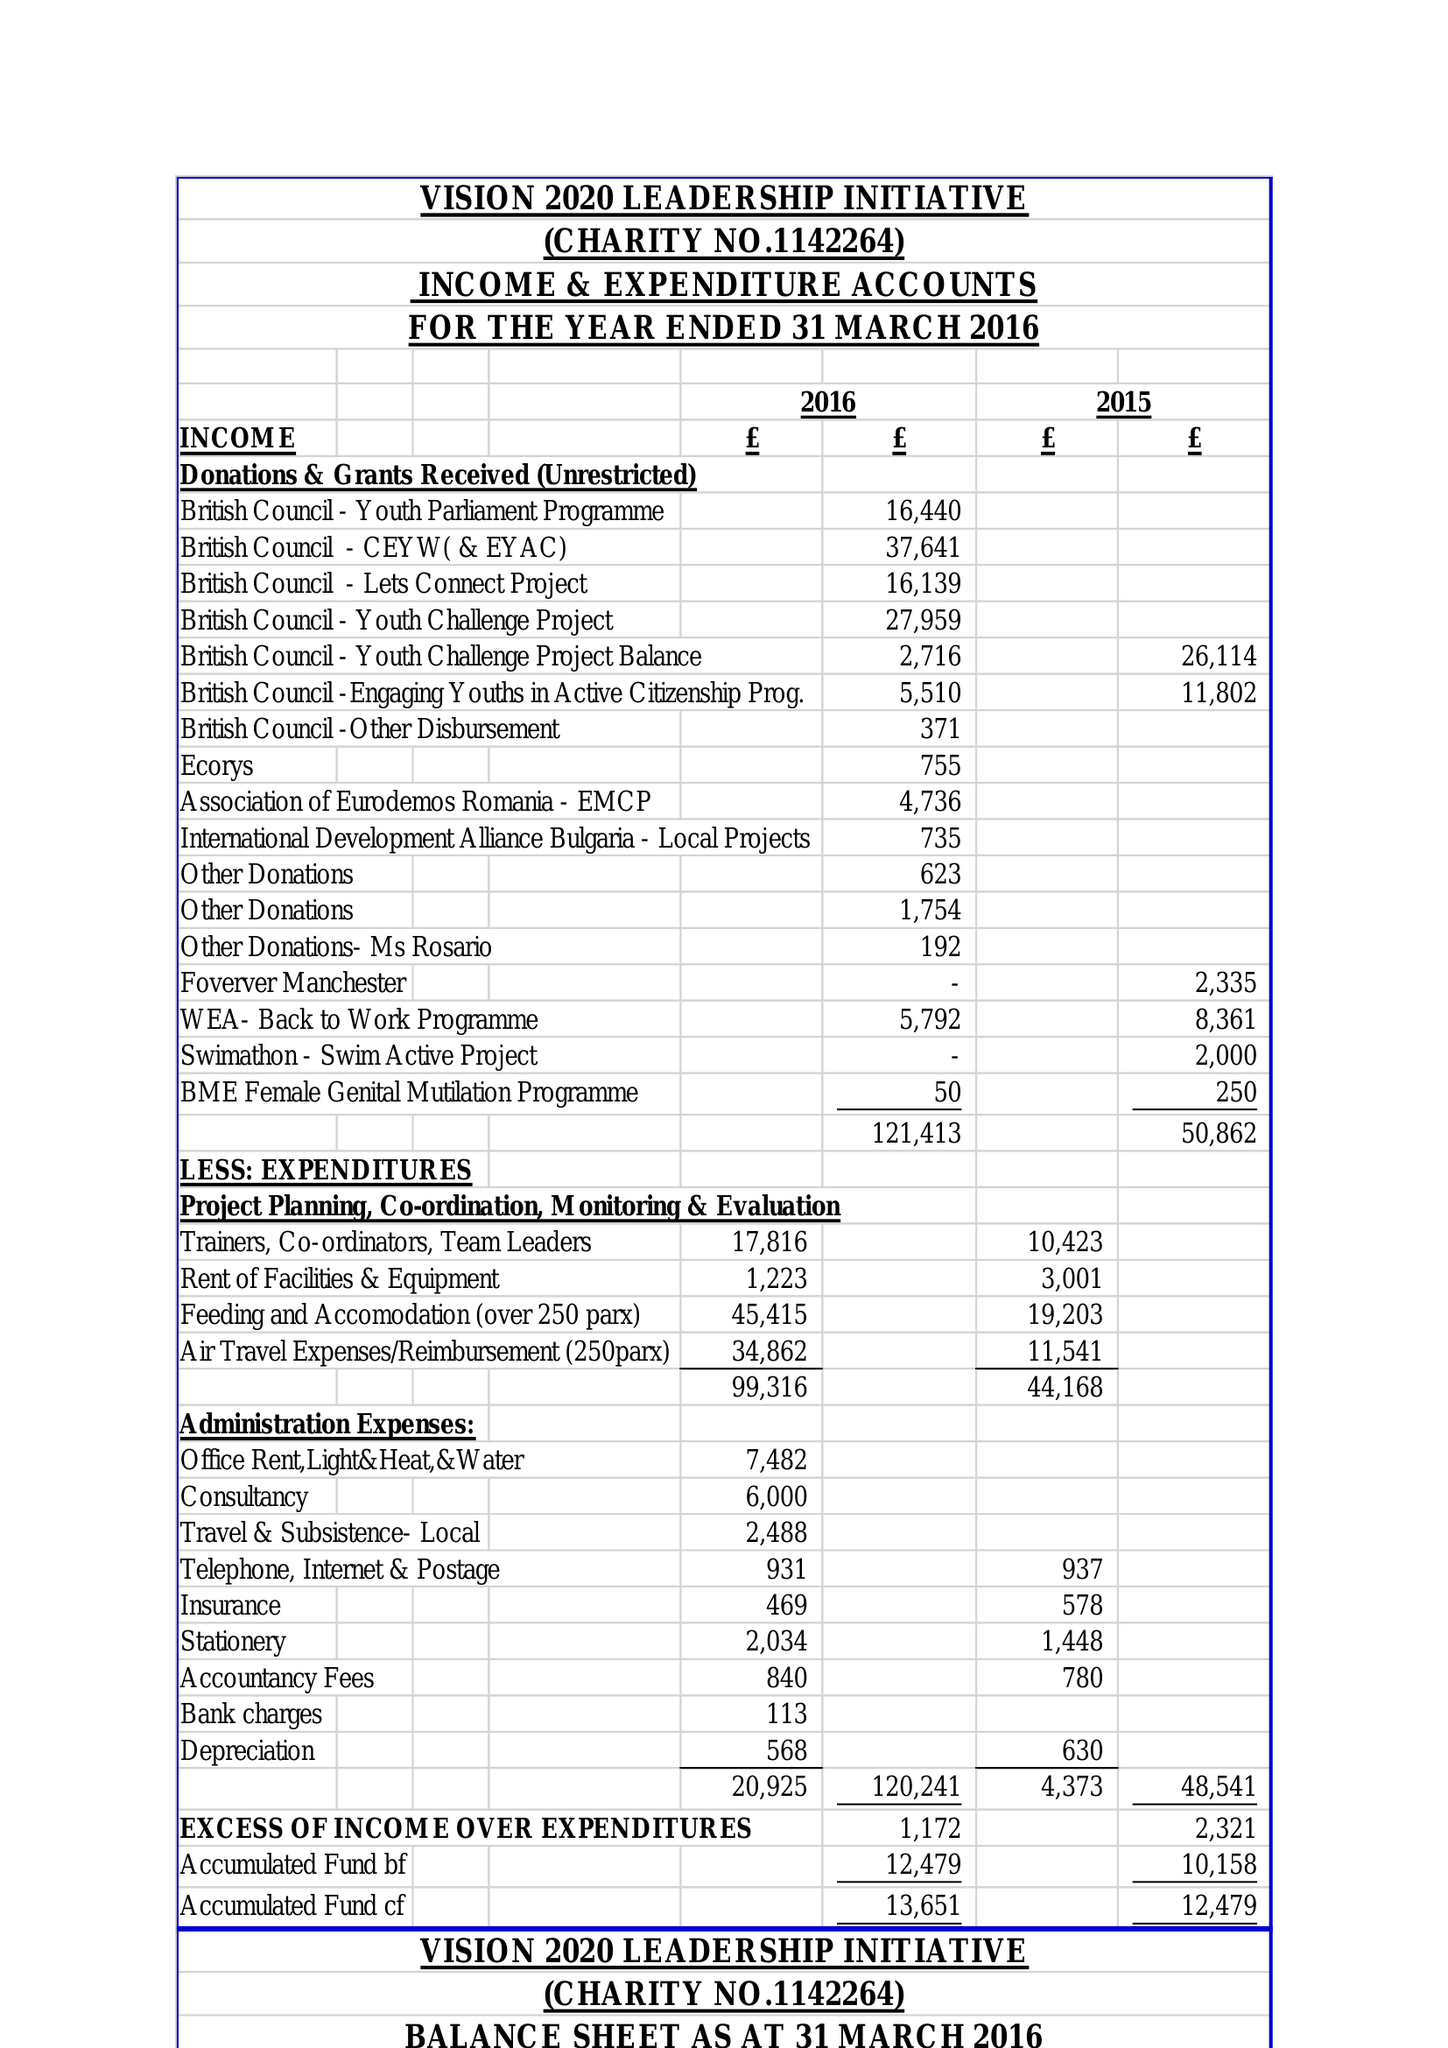What is the value for the spending_annually_in_british_pounds?
Answer the question using a single word or phrase. 120241.00 